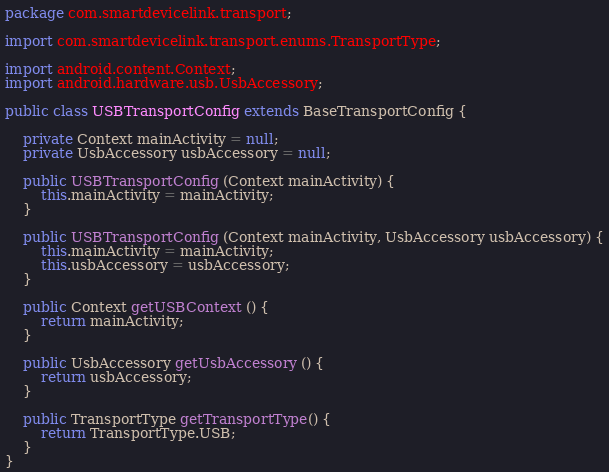<code> <loc_0><loc_0><loc_500><loc_500><_Java_>package com.smartdevicelink.transport;

import com.smartdevicelink.transport.enums.TransportType;

import android.content.Context;
import android.hardware.usb.UsbAccessory;

public class USBTransportConfig extends BaseTransportConfig {
	
	private Context mainActivity = null;
	private UsbAccessory usbAccessory = null;
	
	public USBTransportConfig (Context mainActivity) {
		this.mainActivity = mainActivity;
	}
	
	public USBTransportConfig (Context mainActivity, UsbAccessory usbAccessory) {
		this.mainActivity = mainActivity;
		this.usbAccessory = usbAccessory;
	}
	
	public Context getUSBContext () {
		return mainActivity;
	}
	
	public UsbAccessory getUsbAccessory () {
		return usbAccessory;
	}
	
	public TransportType getTransportType() {
		return TransportType.USB;
	}
}</code> 